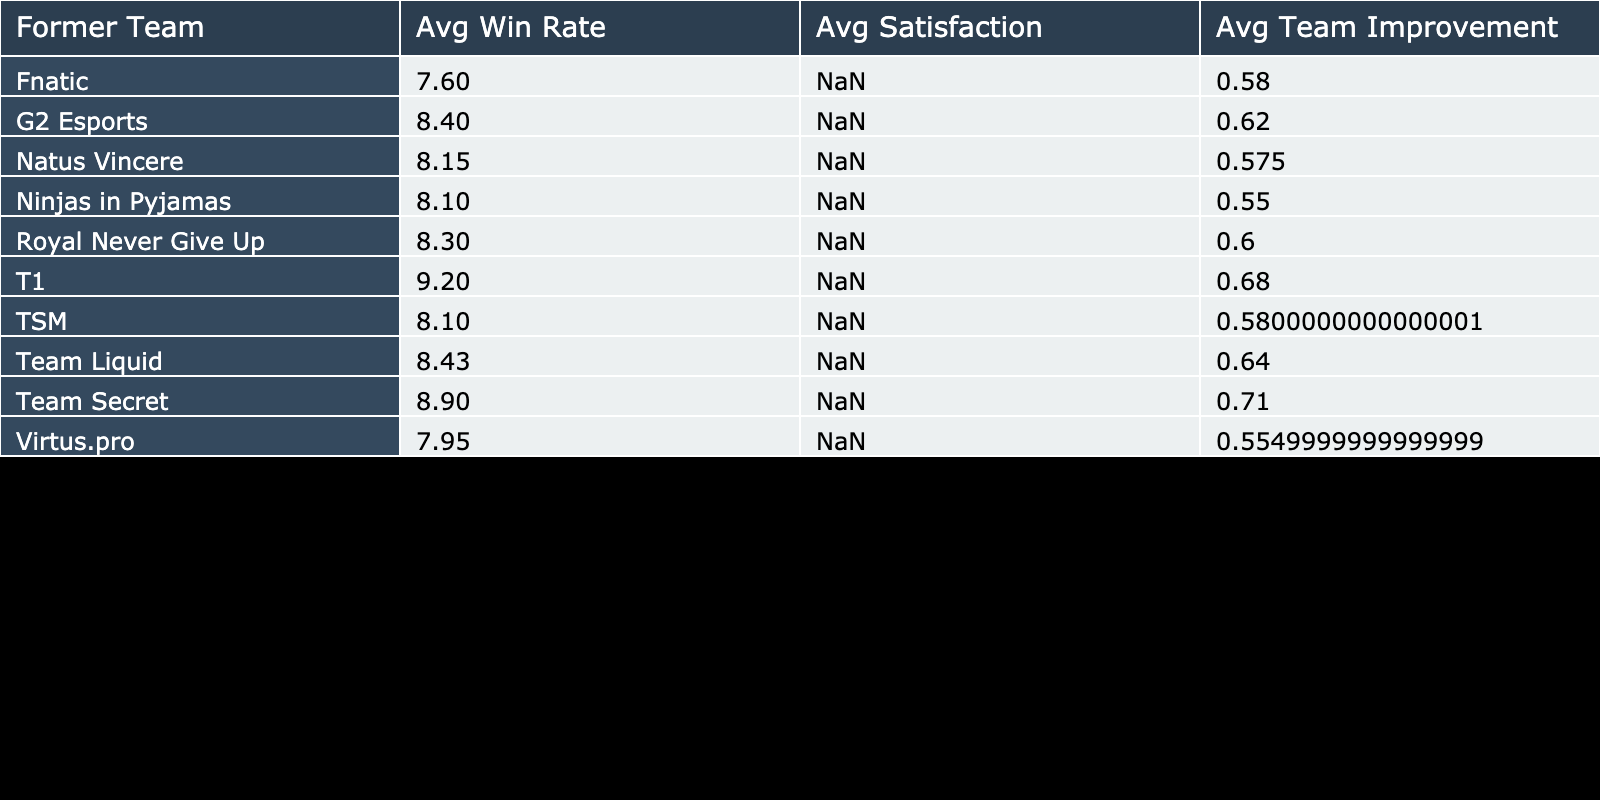What is the average win rate of players from Team Secret who transitioned to coaching? The table shows that Puppey, as a coach from Team Secret, has an average win rate of 0.71, and since he is the only player from Team Secret in the data, the average win rate is simply his win rate.
Answer: 0.71 Which former team had the highest average player satisfaction score after transitioning to coaching? Looking at the table, we can see the player satisfaction scores for each former team and calculate the averages. Team Secret has an average of 8.9, which is higher than any other team's average score.
Answer: Team Secret Did Doublelift have a better average team performance improvement than JW? To answer this, we find Doublelift's team performance improvement (9%) and JW's (5%). Comparing these values, 9% is greater than 5%, meaning Doublelift had a better improvement.
Answer: Yes What is the overall average team performance improvement of all players who transitioned? Adding the team performance improvements for all players gives us a total of 15% + (-5%) + 20% + 10% + 12% + 5% + 8% + 7% + 3% + 6% + 11% + 4% - 2% = 89%. Since there are 12 players, we divide by 12 to get the average: 89% / 12 = 7.42%.
Answer: 7.42% Is it true that every player from Natus Vincere had a win rate above 0.50 after becoming coaches? s1mple has a win rate of 0.63 and Dendi has a win rate of 0.52, both above 0.50. Therefore, both players meet the criteria, making it true that every player from Natus Vincere had a win rate above 0.50.
Answer: Yes 